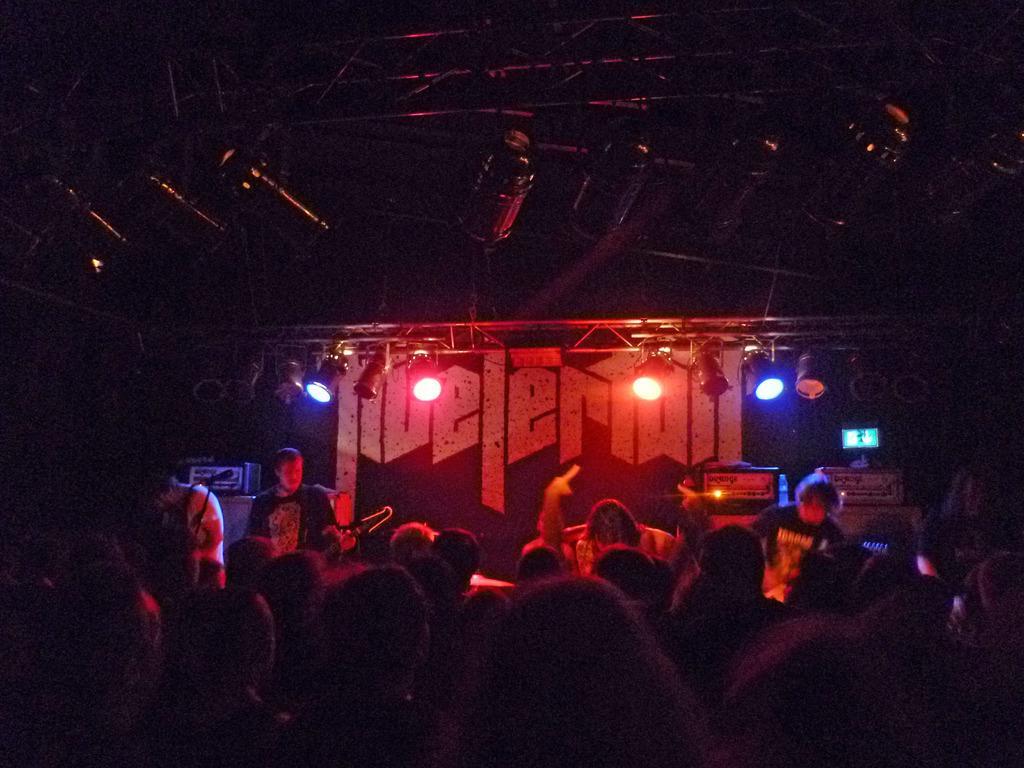Please provide a concise description of this image. In this image we can see a few people, some of them are playing musical instruments, there are electrical objects, there are lights, poles and some electronic objects, the background is dark. 